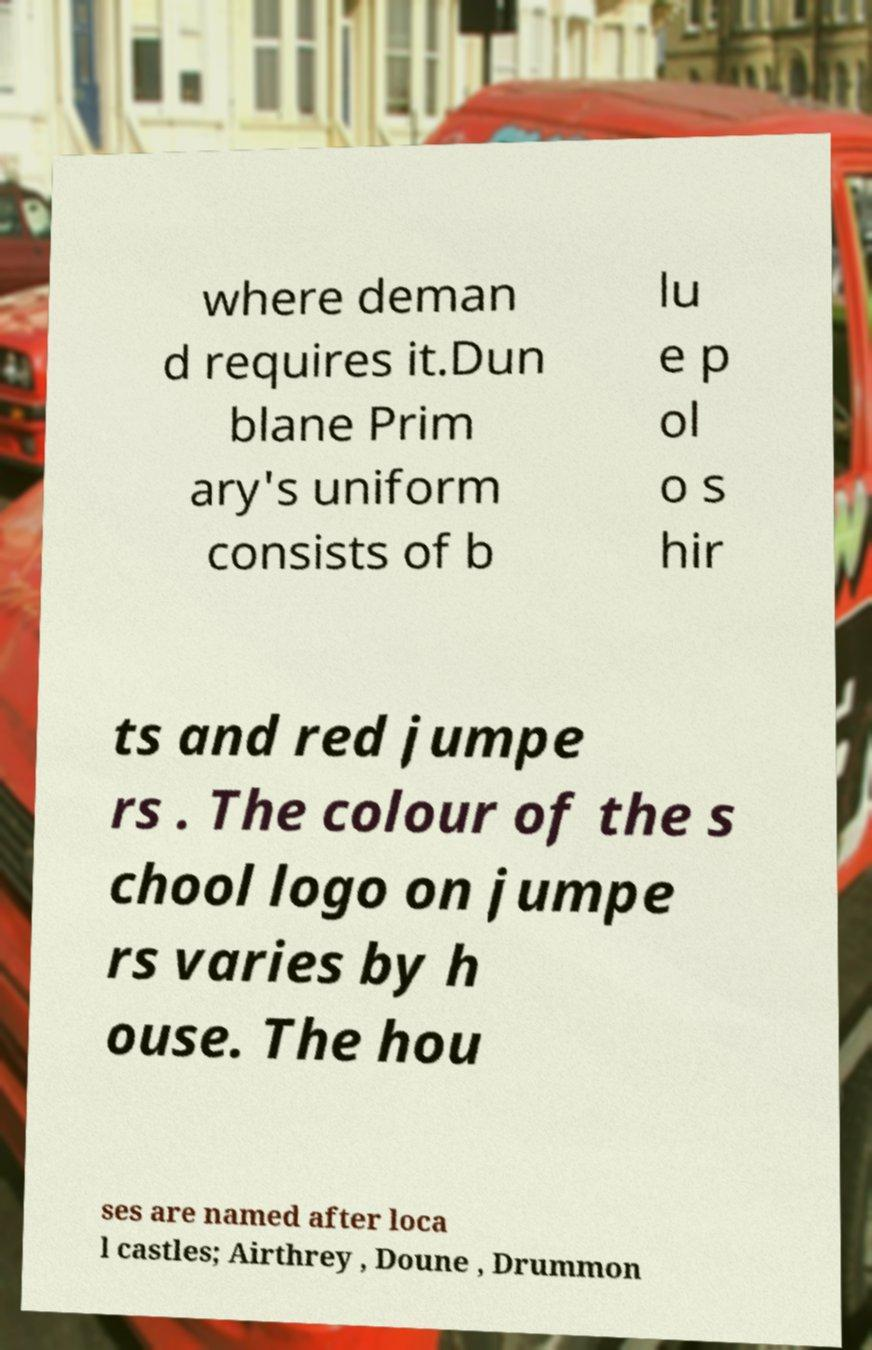I need the written content from this picture converted into text. Can you do that? where deman d requires it.Dun blane Prim ary's uniform consists of b lu e p ol o s hir ts and red jumpe rs . The colour of the s chool logo on jumpe rs varies by h ouse. The hou ses are named after loca l castles; Airthrey , Doune , Drummon 